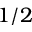Convert formula to latex. <formula><loc_0><loc_0><loc_500><loc_500>1 / 2</formula> 